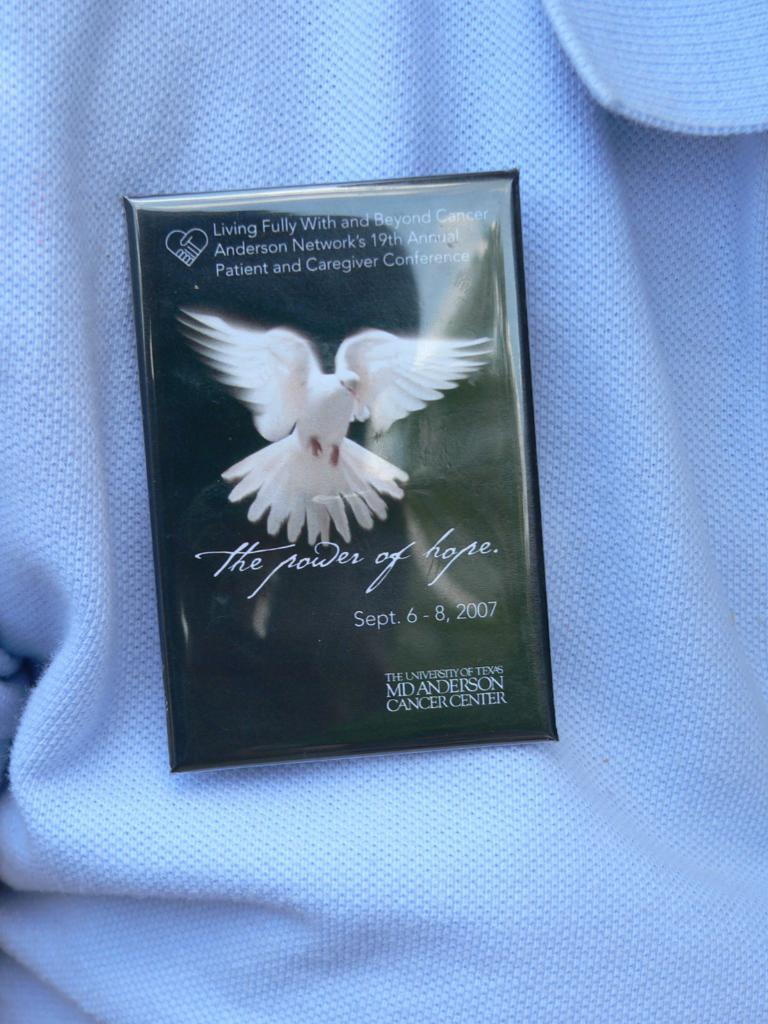What type of clothing item is visible in the image? There is a white T-shirt in the image. What else can be seen in the image besides the T-shirt? There is a card in the image. What is depicted on the card? The card has an image of a bird. Is there any text on the card? Yes, there is text on the card. What type of book can be seen on the mitten in the image? There is no book or mitten present in the image. 